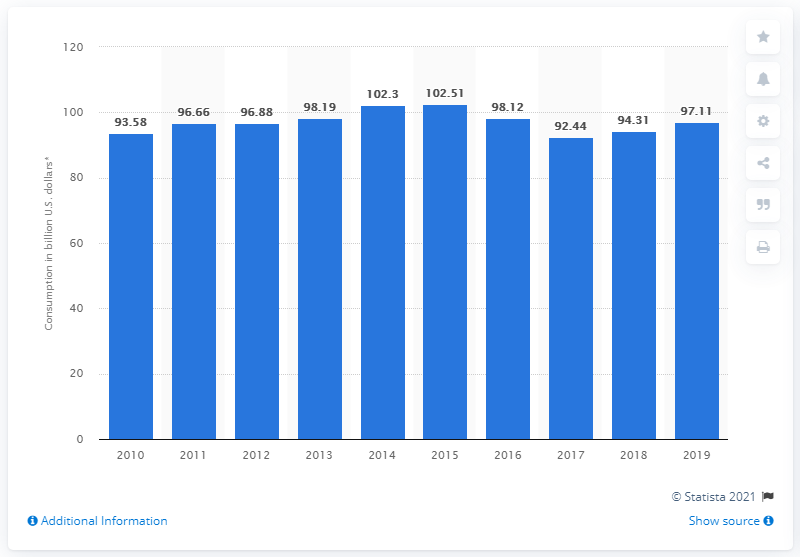Highlight a few significant elements in this photo. In 2014 and 2015, Brazil's annual tourism revenue was 102.51 billion U.S. dollars. In 2019, Brazil's tourism revenue was 97.11. 